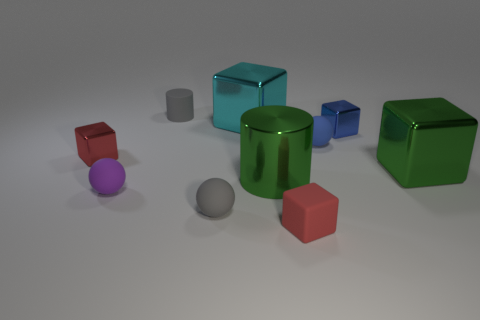Subtract all blue blocks. How many blocks are left? 4 Subtract all matte blocks. How many blocks are left? 4 Subtract all brown blocks. Subtract all red balls. How many blocks are left? 5 Subtract all spheres. How many objects are left? 7 Subtract all cyan shiny cubes. Subtract all large purple matte cubes. How many objects are left? 9 Add 2 purple matte spheres. How many purple matte spheres are left? 3 Add 10 brown rubber balls. How many brown rubber balls exist? 10 Subtract 0 cyan balls. How many objects are left? 10 